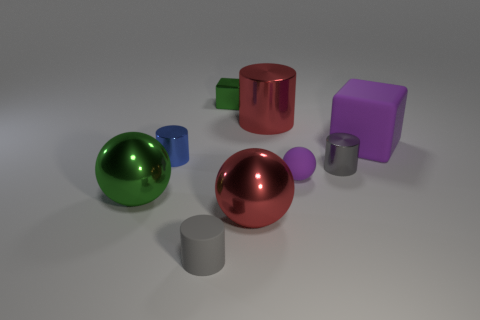Is the color of the matte cube the same as the small ball?
Keep it short and to the point. Yes. The ball that is the same color as the rubber cube is what size?
Your response must be concise. Small. What is the shape of the big red metal object in front of the gray metal cylinder?
Provide a succinct answer. Sphere. The rubber object that is on the right side of the metallic cylinder in front of the tiny blue metallic cylinder is what color?
Provide a short and direct response. Purple. There is a red metallic object that is in front of the big cube; is it the same shape as the large green object that is in front of the small purple matte ball?
Provide a short and direct response. Yes. What is the shape of the purple rubber object that is the same size as the gray shiny cylinder?
Your response must be concise. Sphere. The block that is the same material as the red cylinder is what color?
Your answer should be very brief. Green. There is a large purple object; does it have the same shape as the red metallic thing that is in front of the red metal cylinder?
Offer a very short reply. No. What material is the large thing that is the same color as the rubber sphere?
Your answer should be very brief. Rubber. What material is the green thing that is the same size as the blue thing?
Make the answer very short. Metal. 